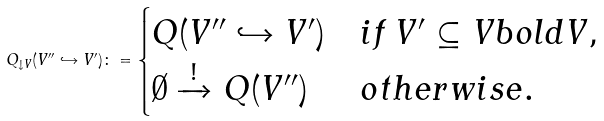Convert formula to latex. <formula><loc_0><loc_0><loc_500><loc_500>Q _ { \downarrow V } ( V ^ { \prime \prime } \hookrightarrow V ^ { \prime } ) \colon = \begin{cases} Q ( V ^ { \prime \prime } \hookrightarrow V ^ { \prime } ) & i f \, V ^ { \prime } \subseteq V b o l d V , \\ \emptyset \xrightarrow { ! } Q ( V ^ { \prime \prime } ) & o t h e r w i s e . \end{cases}</formula> 